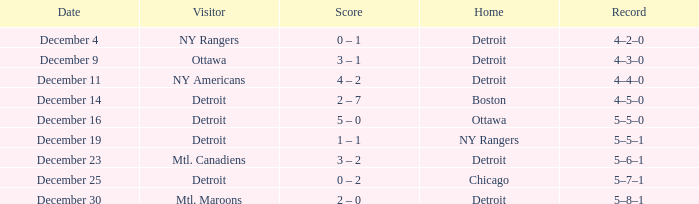What score does mtl. maroons have when playing as the visitor? 2 – 0. 